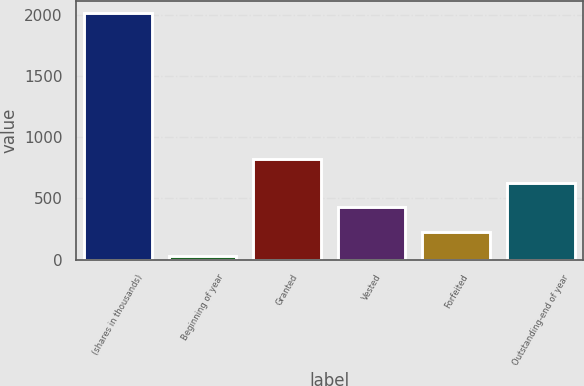Convert chart to OTSL. <chart><loc_0><loc_0><loc_500><loc_500><bar_chart><fcel>(shares in thousands)<fcel>Beginning of year<fcel>Granted<fcel>Vested<fcel>Forfeited<fcel>Outstanding-end of year<nl><fcel>2010<fcel>32.4<fcel>823.44<fcel>427.92<fcel>230.16<fcel>625.68<nl></chart> 